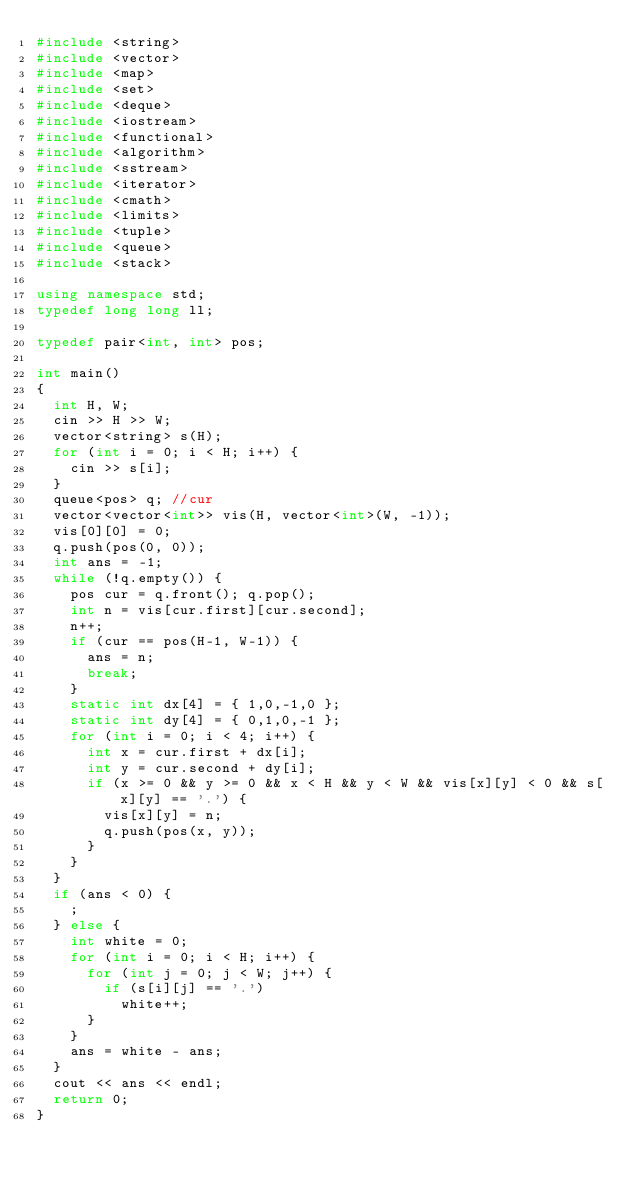<code> <loc_0><loc_0><loc_500><loc_500><_C++_>#include <string>
#include <vector>
#include <map>
#include <set>
#include <deque>
#include <iostream>
#include <functional>
#include <algorithm>
#include <sstream>
#include <iterator>
#include <cmath>
#include <limits>
#include <tuple>
#include <queue>
#include <stack>

using namespace std;
typedef long long ll;

typedef pair<int, int> pos;

int main()
{
	int H, W;
	cin >> H >> W;
	vector<string> s(H);
	for (int i = 0; i < H; i++) {
		cin >> s[i];
	}
	queue<pos> q;	//cur
	vector<vector<int>> vis(H, vector<int>(W, -1));
	vis[0][0] = 0;
	q.push(pos(0, 0));
	int ans = -1;
	while (!q.empty()) {
		pos cur = q.front(); q.pop();
		int n = vis[cur.first][cur.second];
		n++;
		if (cur == pos(H-1, W-1)) {
			ans = n;
			break;
		}
		static int dx[4] = { 1,0,-1,0 };
		static int dy[4] = { 0,1,0,-1 };
		for (int i = 0; i < 4; i++) {
			int x = cur.first + dx[i];
			int y = cur.second + dy[i];
			if (x >= 0 && y >= 0 && x < H && y < W && vis[x][y] < 0 && s[x][y] == '.') {
				vis[x][y] = n;
				q.push(pos(x, y));
			}
		}
	}
	if (ans < 0) {
		;
	} else {
		int white = 0;
		for (int i = 0; i < H; i++) {
			for (int j = 0; j < W; j++) {
				if (s[i][j] == '.')
					white++;
			}
		}
		ans = white - ans;
	}
	cout << ans << endl;
	return 0;
}
</code> 